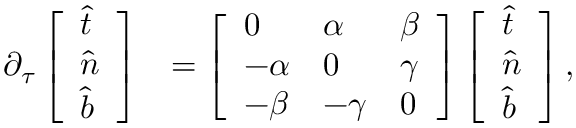<formula> <loc_0><loc_0><loc_500><loc_500>\begin{array} { r l } { \partial _ { \tau } \left [ \begin{array} { l } { \widehat { t } } \\ { \widehat { n } } \\ { \widehat { b } } \end{array} \right ] } & { = \left [ \begin{array} { l l l } { 0 } & { \alpha } & { \beta } \\ { - \alpha } & { 0 } & { \gamma } \\ { - \beta } & { - \gamma } & { 0 } \end{array} \right ] \left [ \begin{array} { l } { \widehat { t } } \\ { \widehat { n } } \\ { \widehat { b } } \end{array} \right ] , } \end{array}</formula> 